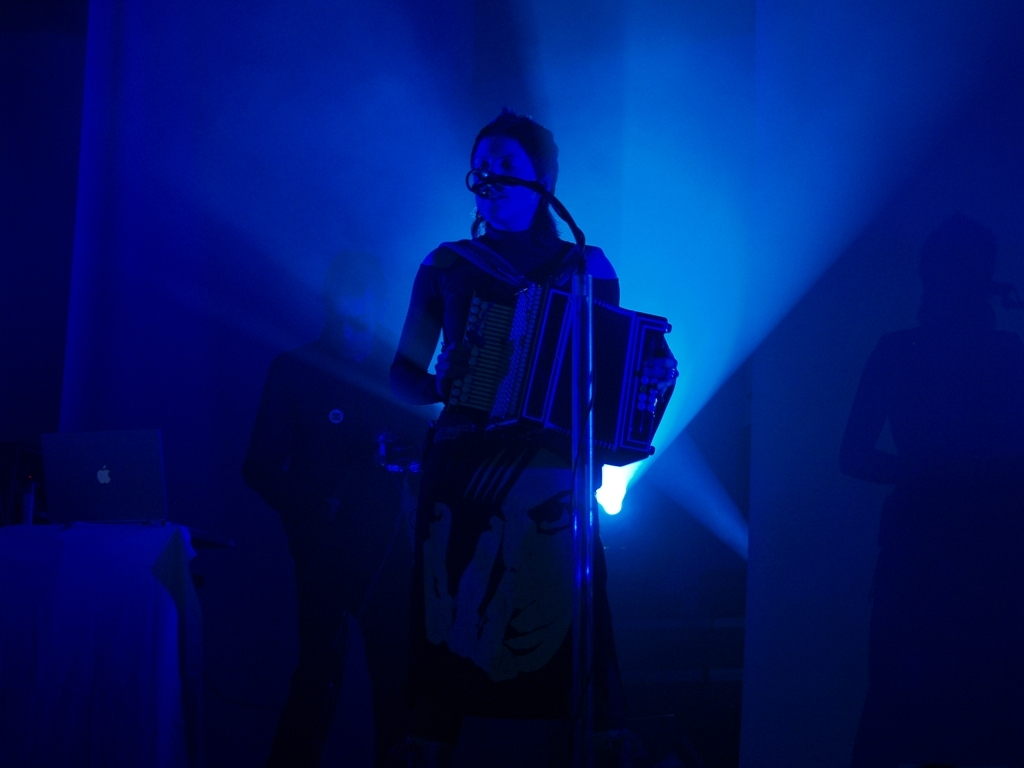What is the mood or atmosphere conveyed by this image? The image presents a dramatic and intimate mood, thanks to the vibrant blue stage lighting and the silhouette effect. It suggests a scene from a live performance with a focus on the solo musician, creating an atmosphere of concentration and artistic expression. Is this image likely from a large concert or a smaller venue? Given the close-up of the musician and the dimly lit background that does not reveal a large crowd or expansive stage setting, it's probable that this performance is taking place in a smaller, more intimate venue. 